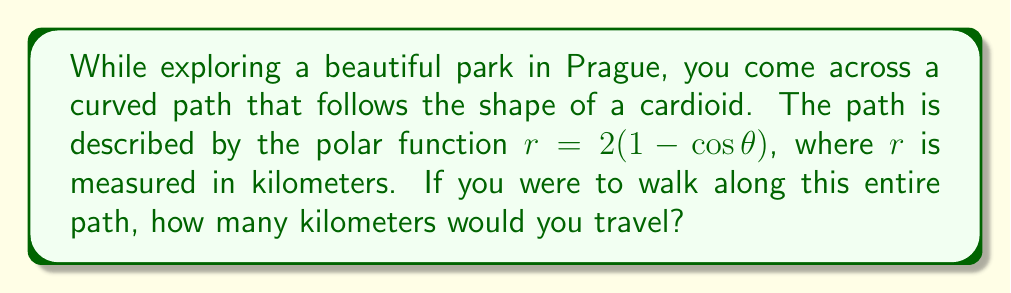Teach me how to tackle this problem. To find the length of a curved path described by a polar function, we use the arc length formula for polar coordinates:

$$L = \int_a^b \sqrt{r^2 + \left(\frac{dr}{d\theta}\right)^2} d\theta$$

For our cardioid function $r = 2(1 - \cos\theta)$, we need to follow these steps:

1) First, find $\frac{dr}{d\theta}$:
   $$\frac{dr}{d\theta} = 2\sin\theta$$

2) Calculate $r^2 + \left(\frac{dr}{d\theta}\right)^2$:
   $$r^2 + \left(\frac{dr}{d\theta}\right)^2 = [2(1-\cos\theta)]^2 + (2\sin\theta)^2$$
   $$= 4(1-2\cos\theta+\cos^2\theta) + 4\sin^2\theta$$
   $$= 4(1-2\cos\theta+\cos^2\theta+\sin^2\theta)$$
   $$= 4(2-2\cos\theta)$$ (since $\cos^2\theta+\sin^2\theta = 1$)
   $$= 8(1-\cos\theta)$$

3) Take the square root:
   $$\sqrt{r^2 + \left(\frac{dr}{d\theta}\right)^2} = \sqrt{8(1-\cos\theta)} = 2\sqrt{2(1-\cos\theta)}$$

4) Set up the integral. A cardioid makes one complete loop as $\theta$ goes from 0 to $2\pi$:
   $$L = \int_0^{2\pi} 2\sqrt{2(1-\cos\theta)} d\theta$$

5) This integral can be evaluated to:
   $$L = 8$$

Therefore, the length of the path is 8 kilometers.
Answer: 8 kilometers 